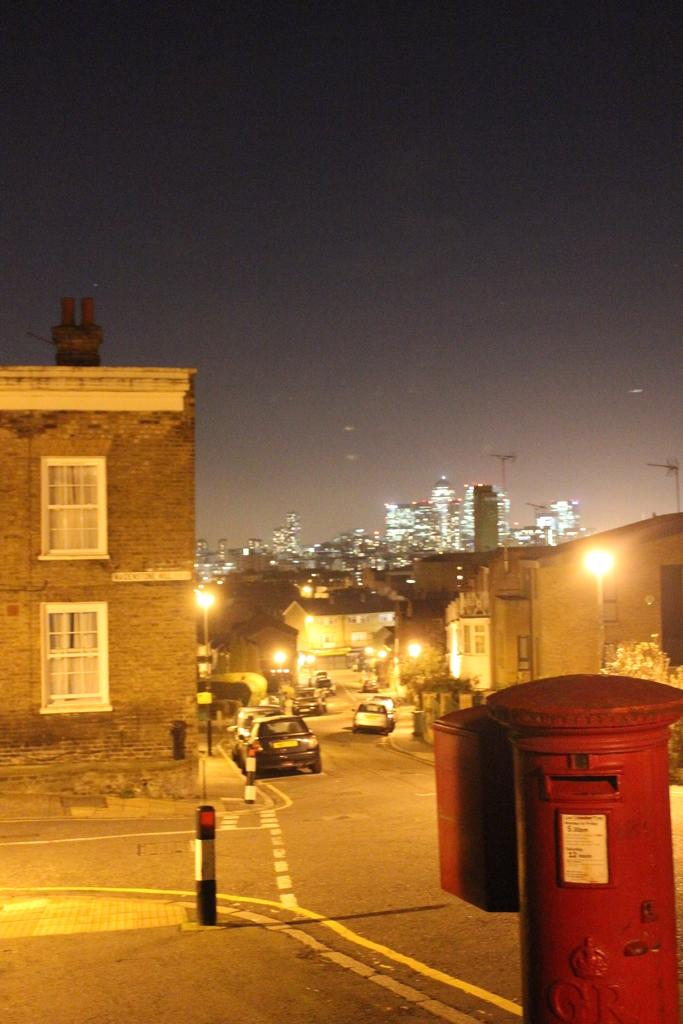What is the main object in the image? There is a post box in the image. What else can be seen in the image besides the post box? There are vehicles on the road, buildings, lights, plants, and the sky is visible in the background. Can you describe the vehicles in the image? The vehicles on the road are not specified, but they are present in the image. What type of lights are in the image? The lights in the image are not specified, but they are present. Where is the maid in the image? There is no maid present in the image. What type of death is depicted in the image? There is no depiction of death in the image. 